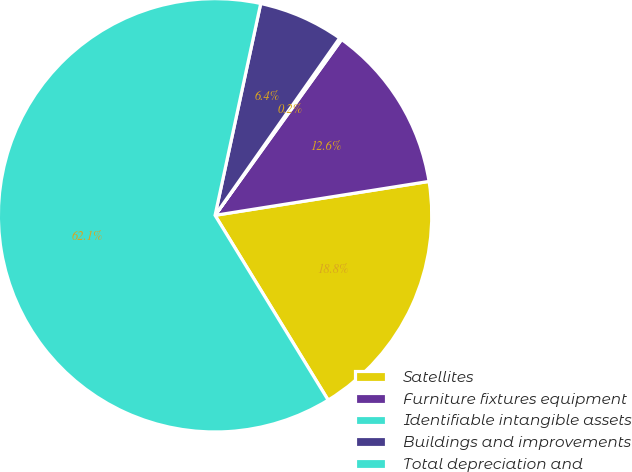Convert chart to OTSL. <chart><loc_0><loc_0><loc_500><loc_500><pie_chart><fcel>Satellites<fcel>Furniture fixtures equipment<fcel>Identifiable intangible assets<fcel>Buildings and improvements<fcel>Total depreciation and<nl><fcel>18.76%<fcel>12.57%<fcel>0.18%<fcel>6.37%<fcel>62.12%<nl></chart> 